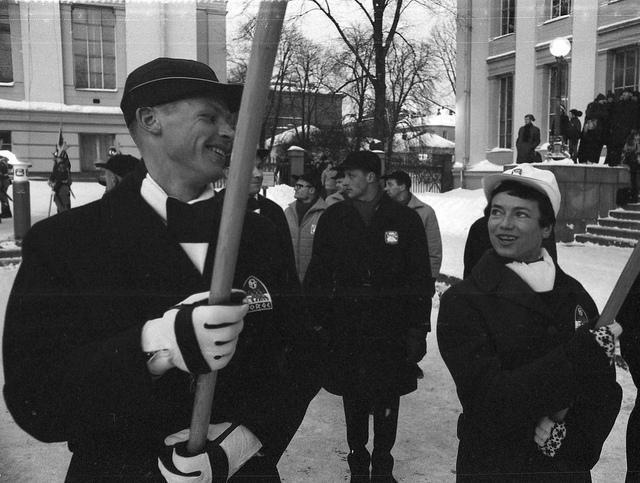How many baseball gloves are in the photo?
Give a very brief answer. 1. How many people can be seen?
Give a very brief answer. 5. 